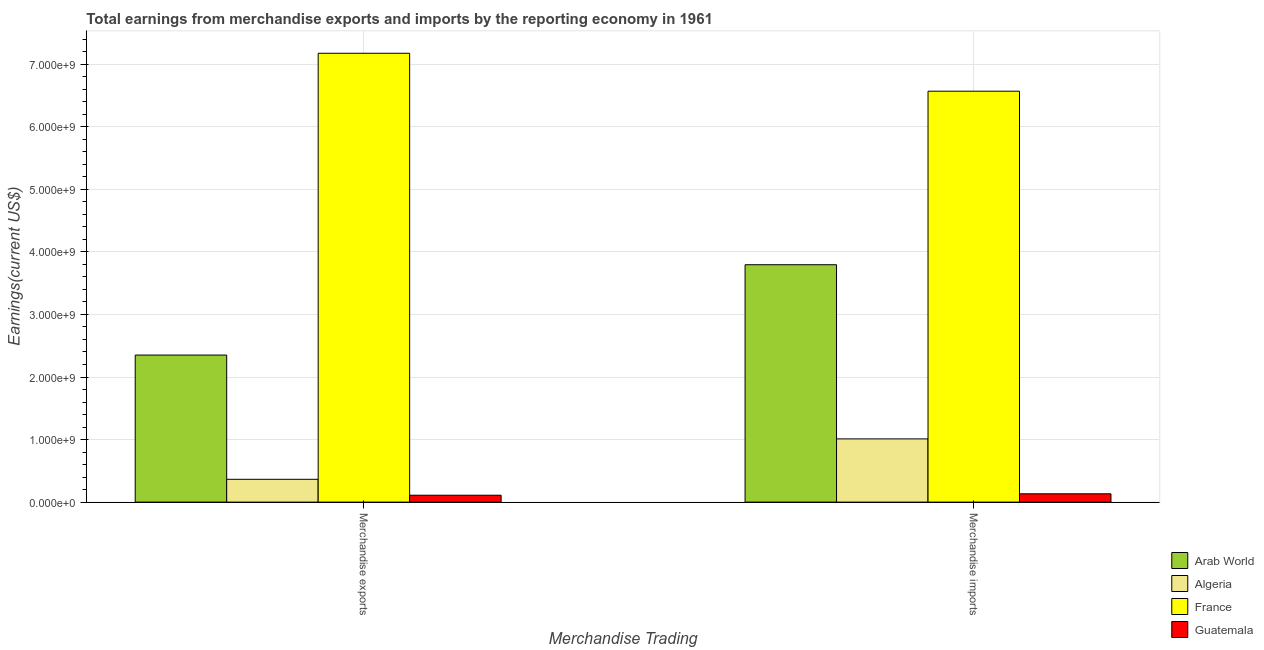How many groups of bars are there?
Keep it short and to the point. 2. Are the number of bars on each tick of the X-axis equal?
Give a very brief answer. Yes. What is the label of the 1st group of bars from the left?
Make the answer very short. Merchandise exports. What is the earnings from merchandise imports in Algeria?
Give a very brief answer. 1.01e+09. Across all countries, what is the maximum earnings from merchandise exports?
Your answer should be compact. 7.17e+09. Across all countries, what is the minimum earnings from merchandise imports?
Make the answer very short. 1.33e+08. In which country was the earnings from merchandise imports maximum?
Ensure brevity in your answer.  France. In which country was the earnings from merchandise exports minimum?
Keep it short and to the point. Guatemala. What is the total earnings from merchandise imports in the graph?
Make the answer very short. 1.15e+1. What is the difference between the earnings from merchandise exports in France and that in Arab World?
Offer a terse response. 4.82e+09. What is the difference between the earnings from merchandise imports in France and the earnings from merchandise exports in Guatemala?
Give a very brief answer. 6.46e+09. What is the average earnings from merchandise exports per country?
Ensure brevity in your answer.  2.50e+09. What is the difference between the earnings from merchandise exports and earnings from merchandise imports in Arab World?
Ensure brevity in your answer.  -1.44e+09. What is the ratio of the earnings from merchandise imports in France to that in Guatemala?
Make the answer very short. 49.35. What does the 4th bar from the left in Merchandise imports represents?
Provide a succinct answer. Guatemala. What does the 1st bar from the right in Merchandise imports represents?
Keep it short and to the point. Guatemala. How many bars are there?
Offer a terse response. 8. What is the difference between two consecutive major ticks on the Y-axis?
Give a very brief answer. 1.00e+09. Are the values on the major ticks of Y-axis written in scientific E-notation?
Your answer should be compact. Yes. Where does the legend appear in the graph?
Offer a terse response. Bottom right. How are the legend labels stacked?
Keep it short and to the point. Vertical. What is the title of the graph?
Keep it short and to the point. Total earnings from merchandise exports and imports by the reporting economy in 1961. Does "New Caledonia" appear as one of the legend labels in the graph?
Ensure brevity in your answer.  No. What is the label or title of the X-axis?
Your answer should be very brief. Merchandise Trading. What is the label or title of the Y-axis?
Provide a short and direct response. Earnings(current US$). What is the Earnings(current US$) in Arab World in Merchandise exports?
Keep it short and to the point. 2.35e+09. What is the Earnings(current US$) in Algeria in Merchandise exports?
Offer a terse response. 3.65e+08. What is the Earnings(current US$) of France in Merchandise exports?
Keep it short and to the point. 7.17e+09. What is the Earnings(current US$) of Guatemala in Merchandise exports?
Your response must be concise. 1.10e+08. What is the Earnings(current US$) of Arab World in Merchandise imports?
Provide a succinct answer. 3.79e+09. What is the Earnings(current US$) in Algeria in Merchandise imports?
Provide a short and direct response. 1.01e+09. What is the Earnings(current US$) of France in Merchandise imports?
Make the answer very short. 6.57e+09. What is the Earnings(current US$) of Guatemala in Merchandise imports?
Offer a terse response. 1.33e+08. Across all Merchandise Trading, what is the maximum Earnings(current US$) of Arab World?
Provide a short and direct response. 3.79e+09. Across all Merchandise Trading, what is the maximum Earnings(current US$) of Algeria?
Offer a terse response. 1.01e+09. Across all Merchandise Trading, what is the maximum Earnings(current US$) of France?
Your answer should be very brief. 7.17e+09. Across all Merchandise Trading, what is the maximum Earnings(current US$) of Guatemala?
Your response must be concise. 1.33e+08. Across all Merchandise Trading, what is the minimum Earnings(current US$) of Arab World?
Ensure brevity in your answer.  2.35e+09. Across all Merchandise Trading, what is the minimum Earnings(current US$) in Algeria?
Provide a short and direct response. 3.65e+08. Across all Merchandise Trading, what is the minimum Earnings(current US$) in France?
Provide a succinct answer. 6.57e+09. Across all Merchandise Trading, what is the minimum Earnings(current US$) of Guatemala?
Offer a very short reply. 1.10e+08. What is the total Earnings(current US$) of Arab World in the graph?
Give a very brief answer. 6.15e+09. What is the total Earnings(current US$) of Algeria in the graph?
Offer a very short reply. 1.38e+09. What is the total Earnings(current US$) in France in the graph?
Your answer should be compact. 1.37e+1. What is the total Earnings(current US$) of Guatemala in the graph?
Give a very brief answer. 2.43e+08. What is the difference between the Earnings(current US$) in Arab World in Merchandise exports and that in Merchandise imports?
Make the answer very short. -1.44e+09. What is the difference between the Earnings(current US$) of Algeria in Merchandise exports and that in Merchandise imports?
Keep it short and to the point. -6.46e+08. What is the difference between the Earnings(current US$) in France in Merchandise exports and that in Merchandise imports?
Give a very brief answer. 6.06e+08. What is the difference between the Earnings(current US$) of Guatemala in Merchandise exports and that in Merchandise imports?
Provide a short and direct response. -2.29e+07. What is the difference between the Earnings(current US$) of Arab World in Merchandise exports and the Earnings(current US$) of Algeria in Merchandise imports?
Your answer should be very brief. 1.34e+09. What is the difference between the Earnings(current US$) in Arab World in Merchandise exports and the Earnings(current US$) in France in Merchandise imports?
Make the answer very short. -4.22e+09. What is the difference between the Earnings(current US$) in Arab World in Merchandise exports and the Earnings(current US$) in Guatemala in Merchandise imports?
Your response must be concise. 2.22e+09. What is the difference between the Earnings(current US$) in Algeria in Merchandise exports and the Earnings(current US$) in France in Merchandise imports?
Make the answer very short. -6.20e+09. What is the difference between the Earnings(current US$) of Algeria in Merchandise exports and the Earnings(current US$) of Guatemala in Merchandise imports?
Ensure brevity in your answer.  2.32e+08. What is the difference between the Earnings(current US$) of France in Merchandise exports and the Earnings(current US$) of Guatemala in Merchandise imports?
Offer a terse response. 7.04e+09. What is the average Earnings(current US$) of Arab World per Merchandise Trading?
Your response must be concise. 3.07e+09. What is the average Earnings(current US$) of Algeria per Merchandise Trading?
Keep it short and to the point. 6.88e+08. What is the average Earnings(current US$) in France per Merchandise Trading?
Give a very brief answer. 6.87e+09. What is the average Earnings(current US$) of Guatemala per Merchandise Trading?
Your response must be concise. 1.22e+08. What is the difference between the Earnings(current US$) of Arab World and Earnings(current US$) of Algeria in Merchandise exports?
Make the answer very short. 1.99e+09. What is the difference between the Earnings(current US$) in Arab World and Earnings(current US$) in France in Merchandise exports?
Your answer should be very brief. -4.82e+09. What is the difference between the Earnings(current US$) of Arab World and Earnings(current US$) of Guatemala in Merchandise exports?
Your response must be concise. 2.24e+09. What is the difference between the Earnings(current US$) in Algeria and Earnings(current US$) in France in Merchandise exports?
Offer a very short reply. -6.81e+09. What is the difference between the Earnings(current US$) in Algeria and Earnings(current US$) in Guatemala in Merchandise exports?
Keep it short and to the point. 2.54e+08. What is the difference between the Earnings(current US$) in France and Earnings(current US$) in Guatemala in Merchandise exports?
Offer a very short reply. 7.06e+09. What is the difference between the Earnings(current US$) of Arab World and Earnings(current US$) of Algeria in Merchandise imports?
Offer a very short reply. 2.78e+09. What is the difference between the Earnings(current US$) of Arab World and Earnings(current US$) of France in Merchandise imports?
Your answer should be compact. -2.77e+09. What is the difference between the Earnings(current US$) in Arab World and Earnings(current US$) in Guatemala in Merchandise imports?
Your answer should be compact. 3.66e+09. What is the difference between the Earnings(current US$) in Algeria and Earnings(current US$) in France in Merchandise imports?
Your answer should be compact. -5.56e+09. What is the difference between the Earnings(current US$) of Algeria and Earnings(current US$) of Guatemala in Merchandise imports?
Provide a short and direct response. 8.78e+08. What is the difference between the Earnings(current US$) in France and Earnings(current US$) in Guatemala in Merchandise imports?
Your answer should be compact. 6.44e+09. What is the ratio of the Earnings(current US$) in Arab World in Merchandise exports to that in Merchandise imports?
Offer a very short reply. 0.62. What is the ratio of the Earnings(current US$) of Algeria in Merchandise exports to that in Merchandise imports?
Provide a succinct answer. 0.36. What is the ratio of the Earnings(current US$) of France in Merchandise exports to that in Merchandise imports?
Offer a terse response. 1.09. What is the ratio of the Earnings(current US$) of Guatemala in Merchandise exports to that in Merchandise imports?
Ensure brevity in your answer.  0.83. What is the difference between the highest and the second highest Earnings(current US$) in Arab World?
Your answer should be compact. 1.44e+09. What is the difference between the highest and the second highest Earnings(current US$) in Algeria?
Keep it short and to the point. 6.46e+08. What is the difference between the highest and the second highest Earnings(current US$) in France?
Offer a terse response. 6.06e+08. What is the difference between the highest and the second highest Earnings(current US$) of Guatemala?
Your answer should be very brief. 2.29e+07. What is the difference between the highest and the lowest Earnings(current US$) in Arab World?
Ensure brevity in your answer.  1.44e+09. What is the difference between the highest and the lowest Earnings(current US$) in Algeria?
Your answer should be very brief. 6.46e+08. What is the difference between the highest and the lowest Earnings(current US$) of France?
Offer a terse response. 6.06e+08. What is the difference between the highest and the lowest Earnings(current US$) of Guatemala?
Your answer should be very brief. 2.29e+07. 